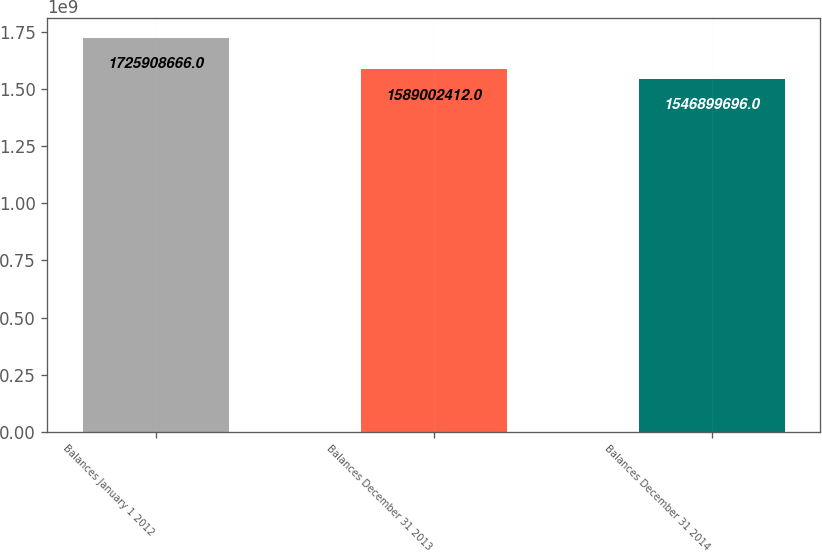Convert chart. <chart><loc_0><loc_0><loc_500><loc_500><bar_chart><fcel>Balances January 1 2012<fcel>Balances December 31 2013<fcel>Balances December 31 2014<nl><fcel>1.72591e+09<fcel>1.589e+09<fcel>1.5469e+09<nl></chart> 